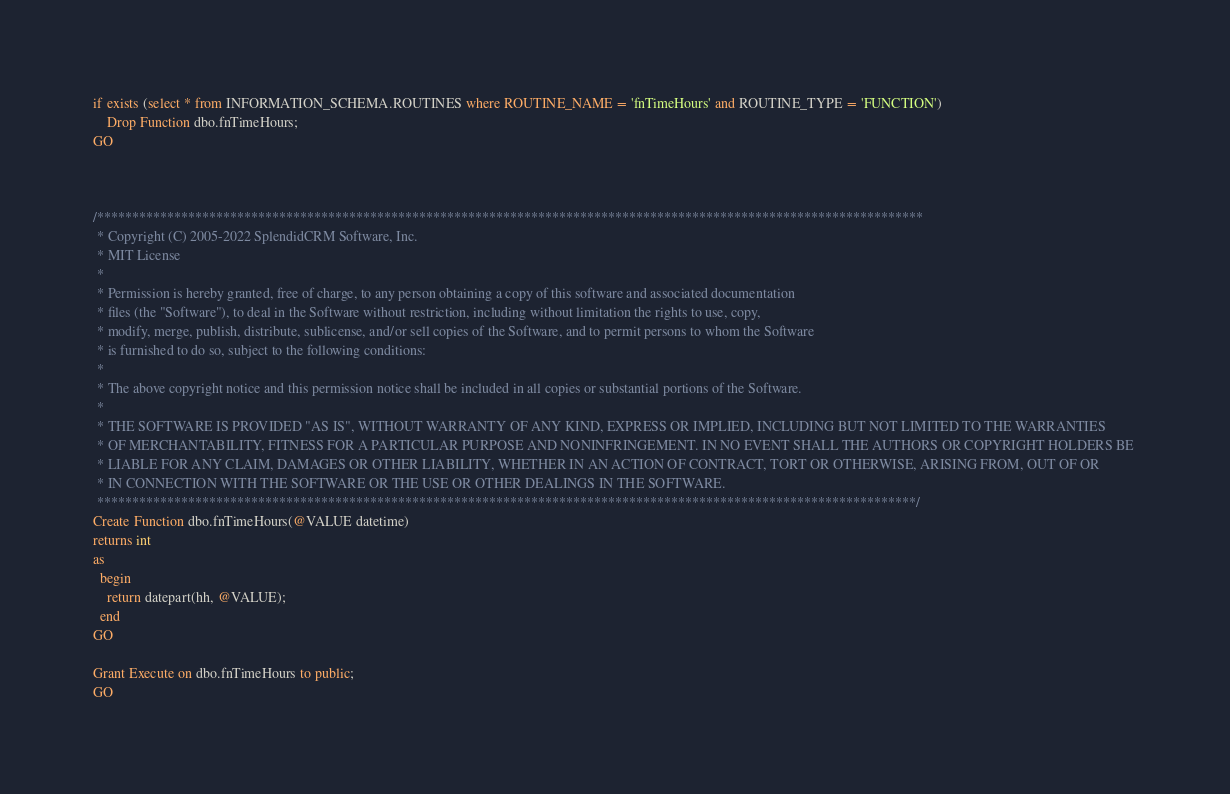Convert code to text. <code><loc_0><loc_0><loc_500><loc_500><_SQL_>if exists (select * from INFORMATION_SCHEMA.ROUTINES where ROUTINE_NAME = 'fnTimeHours' and ROUTINE_TYPE = 'FUNCTION')
	Drop Function dbo.fnTimeHours;
GO



/**********************************************************************************************************************
 * Copyright (C) 2005-2022 SplendidCRM Software, Inc. 
 * MIT License
 * 
 * Permission is hereby granted, free of charge, to any person obtaining a copy of this software and associated documentation 
 * files (the "Software"), to deal in the Software without restriction, including without limitation the rights to use, copy, 
 * modify, merge, publish, distribute, sublicense, and/or sell copies of the Software, and to permit persons to whom the Software 
 * is furnished to do so, subject to the following conditions:
 * 
 * The above copyright notice and this permission notice shall be included in all copies or substantial portions of the Software.
 * 
 * THE SOFTWARE IS PROVIDED "AS IS", WITHOUT WARRANTY OF ANY KIND, EXPRESS OR IMPLIED, INCLUDING BUT NOT LIMITED TO THE WARRANTIES 
 * OF MERCHANTABILITY, FITNESS FOR A PARTICULAR PURPOSE AND NONINFRINGEMENT. IN NO EVENT SHALL THE AUTHORS OR COPYRIGHT HOLDERS BE 
 * LIABLE FOR ANY CLAIM, DAMAGES OR OTHER LIABILITY, WHETHER IN AN ACTION OF CONTRACT, TORT OR OTHERWISE, ARISING FROM, OUT OF OR 
 * IN CONNECTION WITH THE SOFTWARE OR THE USE OR OTHER DEALINGS IN THE SOFTWARE.
 *********************************************************************************************************************/
Create Function dbo.fnTimeHours(@VALUE datetime)
returns int
as
  begin
	return datepart(hh, @VALUE);
  end
GO

Grant Execute on dbo.fnTimeHours to public;
GO

</code> 